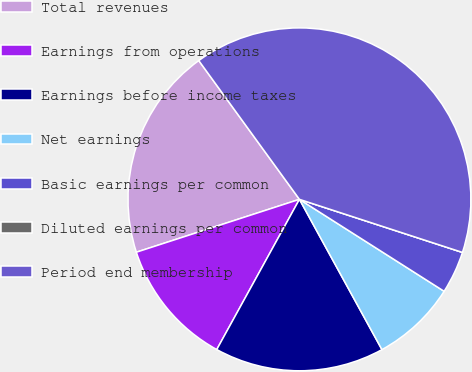Convert chart to OTSL. <chart><loc_0><loc_0><loc_500><loc_500><pie_chart><fcel>Total revenues<fcel>Earnings from operations<fcel>Earnings before income taxes<fcel>Net earnings<fcel>Basic earnings per common<fcel>Diluted earnings per common<fcel>Period end membership<nl><fcel>20.0%<fcel>12.0%<fcel>16.0%<fcel>8.0%<fcel>4.0%<fcel>0.0%<fcel>40.0%<nl></chart> 